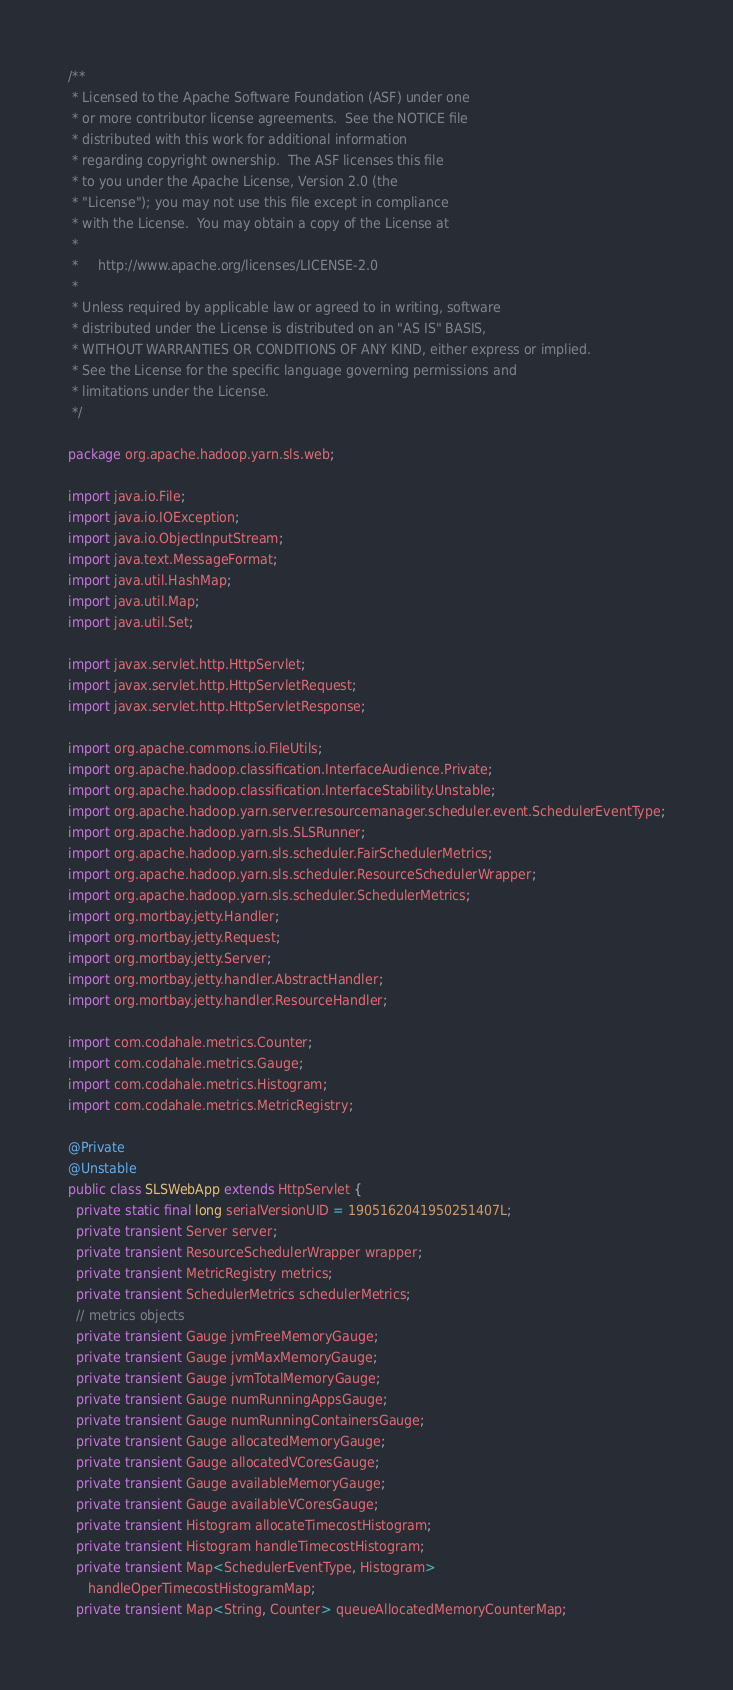Convert code to text. <code><loc_0><loc_0><loc_500><loc_500><_Java_>/**
 * Licensed to the Apache Software Foundation (ASF) under one
 * or more contributor license agreements.  See the NOTICE file
 * distributed with this work for additional information
 * regarding copyright ownership.  The ASF licenses this file
 * to you under the Apache License, Version 2.0 (the
 * "License"); you may not use this file except in compliance
 * with the License.  You may obtain a copy of the License at
 *
 *     http://www.apache.org/licenses/LICENSE-2.0
 *
 * Unless required by applicable law or agreed to in writing, software
 * distributed under the License is distributed on an "AS IS" BASIS,
 * WITHOUT WARRANTIES OR CONDITIONS OF ANY KIND, either express or implied.
 * See the License for the specific language governing permissions and
 * limitations under the License.
 */

package org.apache.hadoop.yarn.sls.web;

import java.io.File;
import java.io.IOException;
import java.io.ObjectInputStream;
import java.text.MessageFormat;
import java.util.HashMap;
import java.util.Map;
import java.util.Set;

import javax.servlet.http.HttpServlet;
import javax.servlet.http.HttpServletRequest;
import javax.servlet.http.HttpServletResponse;

import org.apache.commons.io.FileUtils;
import org.apache.hadoop.classification.InterfaceAudience.Private;
import org.apache.hadoop.classification.InterfaceStability.Unstable;
import org.apache.hadoop.yarn.server.resourcemanager.scheduler.event.SchedulerEventType;
import org.apache.hadoop.yarn.sls.SLSRunner;
import org.apache.hadoop.yarn.sls.scheduler.FairSchedulerMetrics;
import org.apache.hadoop.yarn.sls.scheduler.ResourceSchedulerWrapper;
import org.apache.hadoop.yarn.sls.scheduler.SchedulerMetrics;
import org.mortbay.jetty.Handler;
import org.mortbay.jetty.Request;
import org.mortbay.jetty.Server;
import org.mortbay.jetty.handler.AbstractHandler;
import org.mortbay.jetty.handler.ResourceHandler;

import com.codahale.metrics.Counter;
import com.codahale.metrics.Gauge;
import com.codahale.metrics.Histogram;
import com.codahale.metrics.MetricRegistry;

@Private
@Unstable
public class SLSWebApp extends HttpServlet {
  private static final long serialVersionUID = 1905162041950251407L;
  private transient Server server;
  private transient ResourceSchedulerWrapper wrapper;
  private transient MetricRegistry metrics;
  private transient SchedulerMetrics schedulerMetrics;
  // metrics objects
  private transient Gauge jvmFreeMemoryGauge;
  private transient Gauge jvmMaxMemoryGauge;
  private transient Gauge jvmTotalMemoryGauge;
  private transient Gauge numRunningAppsGauge;
  private transient Gauge numRunningContainersGauge;
  private transient Gauge allocatedMemoryGauge;
  private transient Gauge allocatedVCoresGauge;
  private transient Gauge availableMemoryGauge;
  private transient Gauge availableVCoresGauge;
  private transient Histogram allocateTimecostHistogram;
  private transient Histogram handleTimecostHistogram;
  private transient Map<SchedulerEventType, Histogram>
     handleOperTimecostHistogramMap;
  private transient Map<String, Counter> queueAllocatedMemoryCounterMap;</code> 